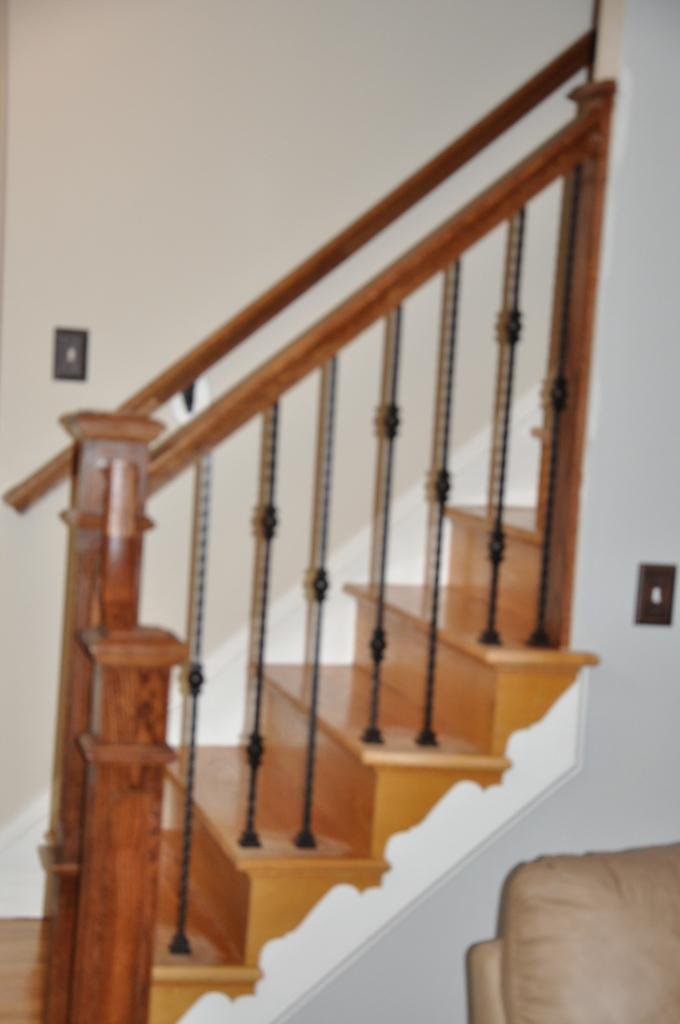What type of structure is present in the image? There is a staircase in the image. What is the color of the staircase? The staircase is in brown color. What else can be seen in the image besides the staircase? There is a wall in the image. Where is the hospital located in the image? There is no hospital present in the image; it only features a brown staircase and a wall. Is there a team of people visible in the image? There is no team of people present in the image; it only features a brown staircase and a wall. 